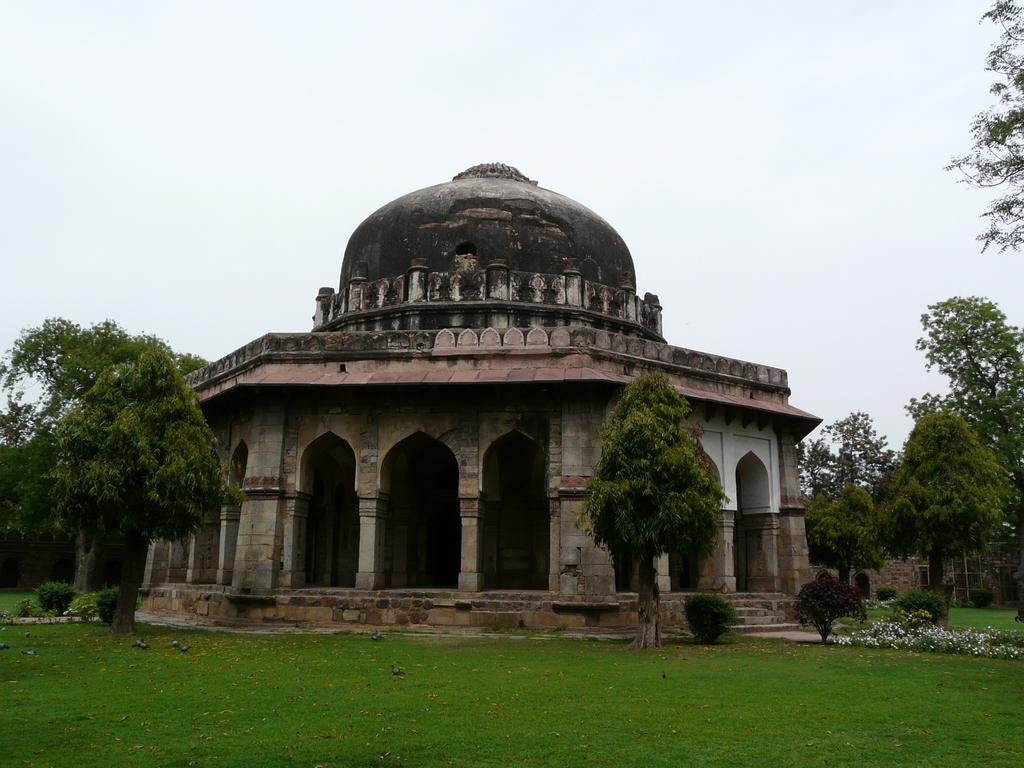What type of structure is present in the image? There is a building in the image. What other natural elements can be seen in the image? There are trees and green grass in the image. Are there any architectural features visible in the image? Yes, there are stairs in the image. What is the color of the sky in the image? The sky is white in color. How many geese are balancing on the judge's head in the image? There are no geese or judges present in the image. 